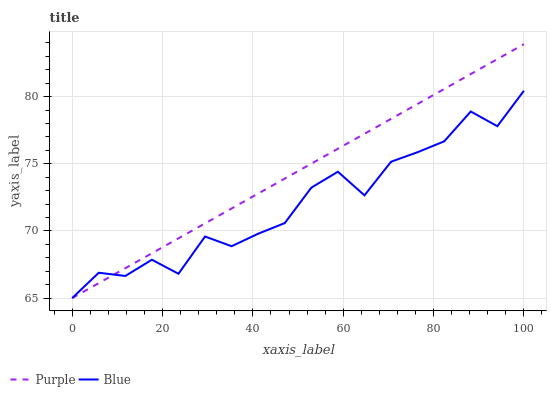Does Blue have the maximum area under the curve?
Answer yes or no. No. Is Blue the smoothest?
Answer yes or no. No. Does Blue have the highest value?
Answer yes or no. No. 